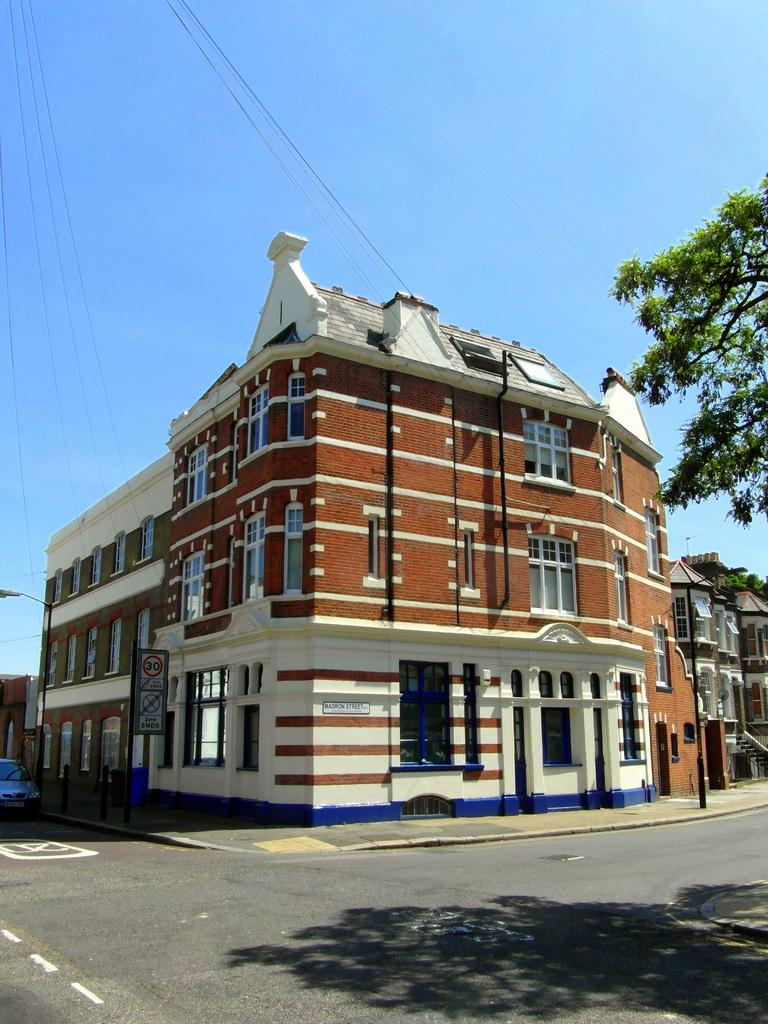What is the main feature of the image? There is a road in the image. What else can be seen in the image besides the road? There is a tree, buildings, lights, boards on poles, a car, wires, and the sky visible in the background of the image. What type of cap is the country wearing in the image? There is no country or cap present in the image. How does the car stop in the image? The car does not stop in the image; it is stationary in the background. 